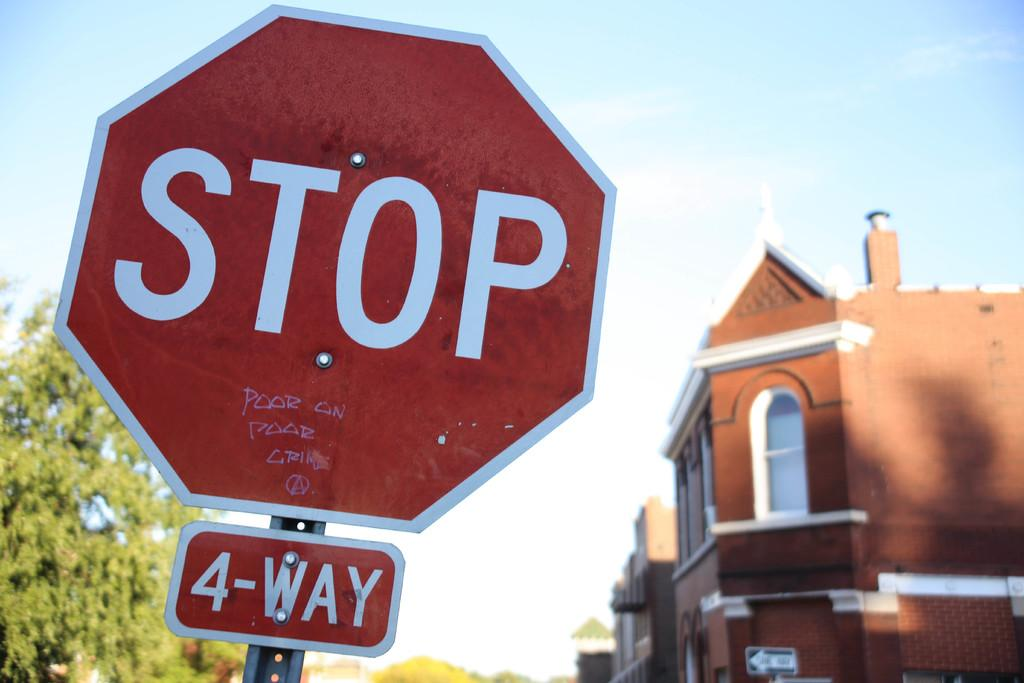<image>
Give a short and clear explanation of the subsequent image. A stop sign with poor on poor crime written on it. 